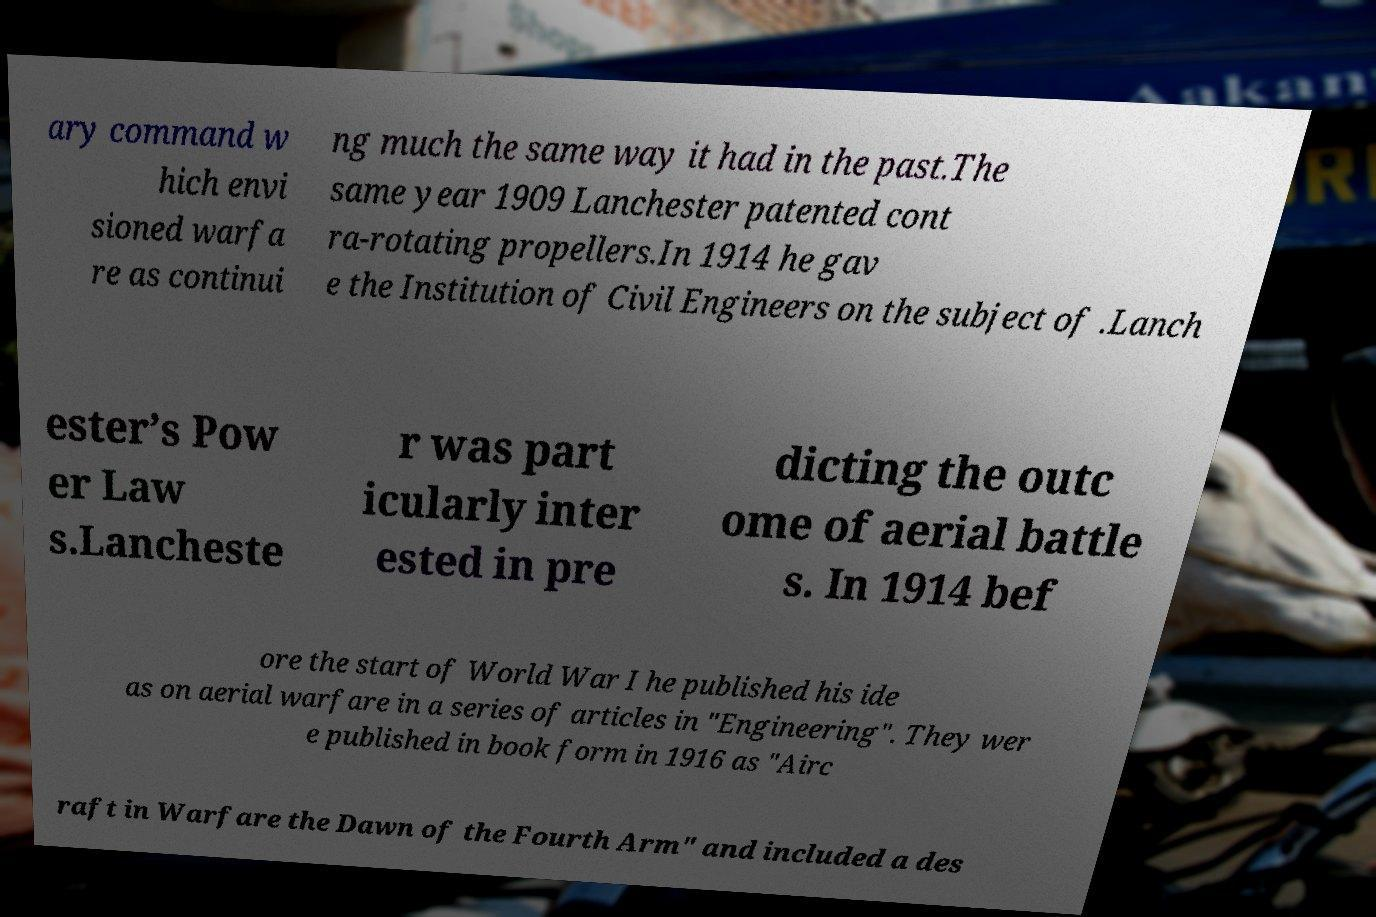For documentation purposes, I need the text within this image transcribed. Could you provide that? ary command w hich envi sioned warfa re as continui ng much the same way it had in the past.The same year 1909 Lanchester patented cont ra-rotating propellers.In 1914 he gav e the Institution of Civil Engineers on the subject of .Lanch ester’s Pow er Law s.Lancheste r was part icularly inter ested in pre dicting the outc ome of aerial battle s. In 1914 bef ore the start of World War I he published his ide as on aerial warfare in a series of articles in "Engineering". They wer e published in book form in 1916 as "Airc raft in Warfare the Dawn of the Fourth Arm" and included a des 